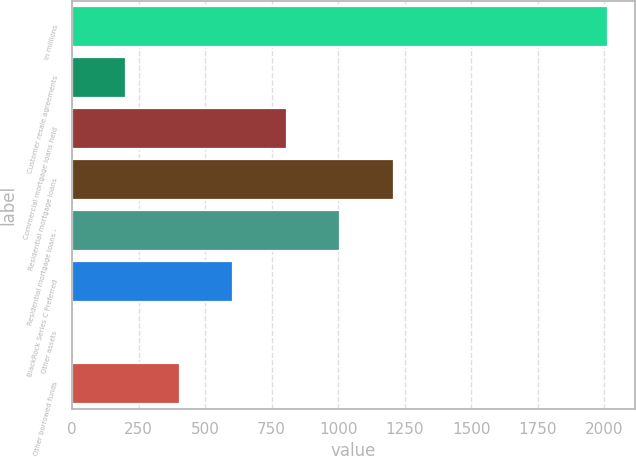Convert chart to OTSL. <chart><loc_0><loc_0><loc_500><loc_500><bar_chart><fcel>In millions<fcel>Customer resale agreements<fcel>Commercial mortgage loans held<fcel>Residential mortgage loans<fcel>Residential mortgage loans -<fcel>BlackRock Series C Preferred<fcel>Other assets<fcel>Other borrowed funds<nl><fcel>2014<fcel>203.2<fcel>806.8<fcel>1209.2<fcel>1008<fcel>605.6<fcel>2<fcel>404.4<nl></chart> 